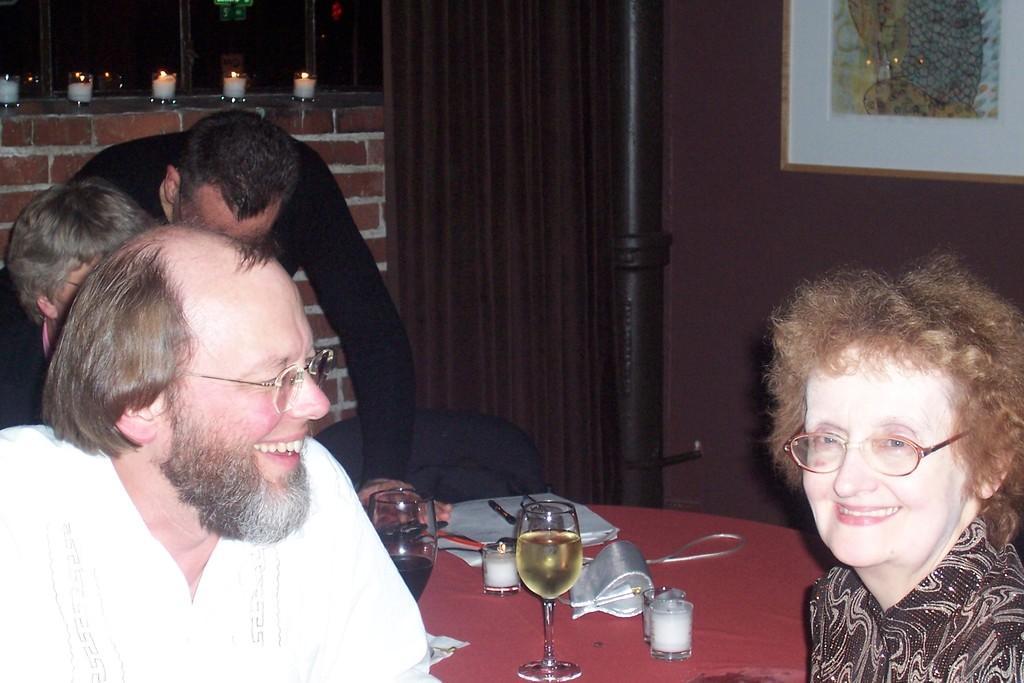In one or two sentences, can you explain what this image depicts? Here we can see persons and we can see glasses,book and some objects on table. On the background we can see frame on wall,curtain,candles and window. 